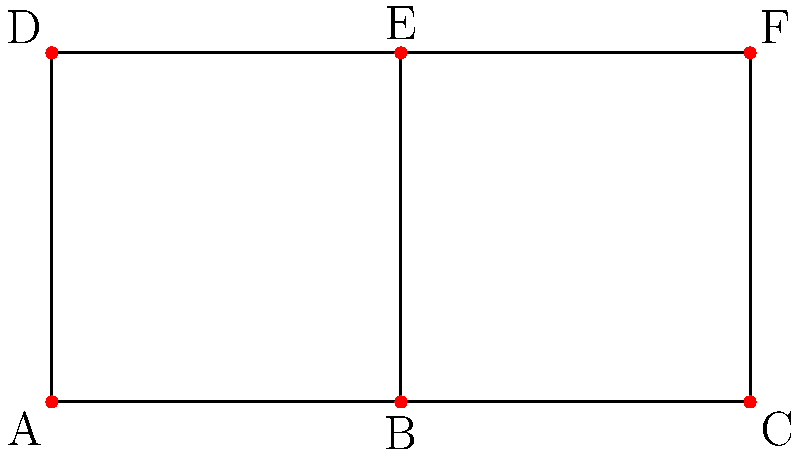Consider the simplicial complex representing the organizational structure of women's military units during World War II, as shown in the diagram. Calculate the first homology group $H_1$ of this complex. To calculate the first homology group $H_1$, we need to follow these steps:

1. Identify the simplices:
   0-simplices: A, B, C, D, E, F
   1-simplices: AB, BC, AD, BE, CF, DE, EF

2. Calculate the boundary maps:
   $\partial_1: C_1 \rightarrow C_0$
   $\partial_1(AB) = B - A$
   $\partial_1(BC) = C - B$
   $\partial_1(AD) = D - A$
   $\partial_1(BE) = E - B$
   $\partial_1(CF) = F - C$
   $\partial_1(DE) = E - D$
   $\partial_1(EF) = F - E$

3. Find the kernel of $\partial_1$ (cycles):
   $ker(\partial_1) = \{aAB + bBC + cAD + dBE + eCF + fDE + gEF | a+b=0, a+c=0, b+d-f=0, c+f-g=0, d+g=0, e-g=0\}$
   This gives us two independent cycles: ABCDA and BEFC

4. Find the image of $\partial_2$:
   There are no 2-simplices in this complex, so $im(\partial_2) = \{0\}$

5. Calculate $H_1 = ker(\partial_1) / im(\partial_2)$:
   Since $im(\partial_2) = \{0\}$, $H_1$ is isomorphic to $ker(\partial_1)$

6. Determine the rank of $H_1$:
   The rank of $H_1$ is equal to the number of independent cycles, which is 2

Therefore, the first homology group $H_1$ is isomorphic to $\mathbb{Z} \oplus \mathbb{Z}$.
Answer: $H_1 \cong \mathbb{Z} \oplus \mathbb{Z}$ 